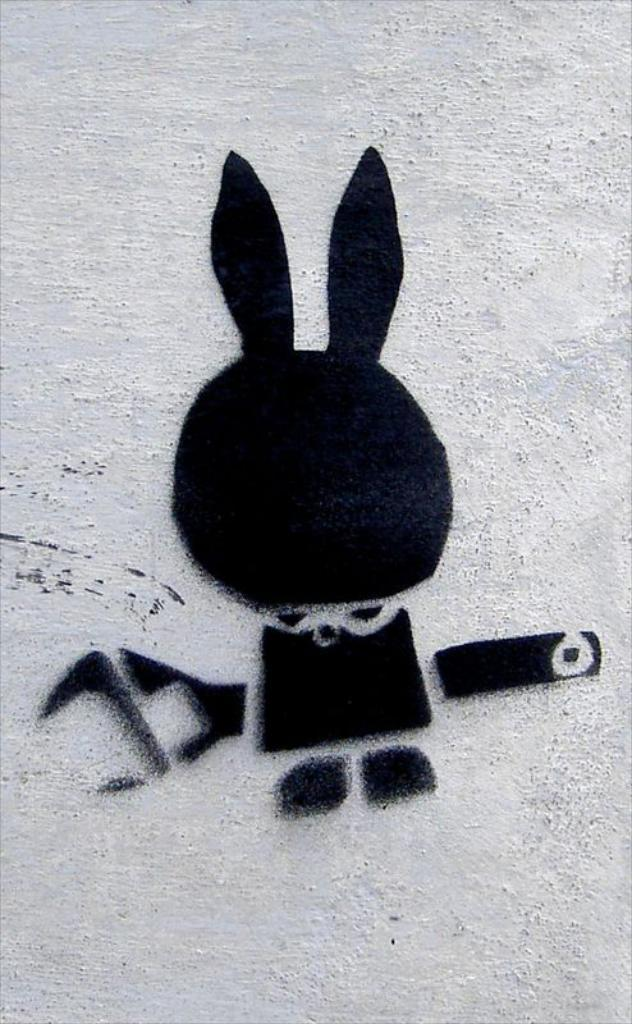What is depicted on the wall in the image? There is graffiti on a wall in the image. Where is the graffiti located in relation to the image? The graffiti is located in the center of the image. How does the graffiti cause the wall to expand in the image? The graffiti does not cause the wall to expand in the image; it is simply a painted design on the wall. 